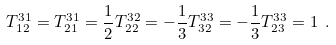Convert formula to latex. <formula><loc_0><loc_0><loc_500><loc_500>T ^ { 3 1 } _ { 1 2 } = T ^ { 3 1 } _ { 2 1 } = \frac { 1 } { 2 } T ^ { 3 2 } _ { 2 2 } = - \frac { 1 } { 3 } T ^ { 3 3 } _ { 3 2 } = - \frac { 1 } { 3 } T ^ { 3 3 } _ { 2 3 } = 1 \ .</formula> 